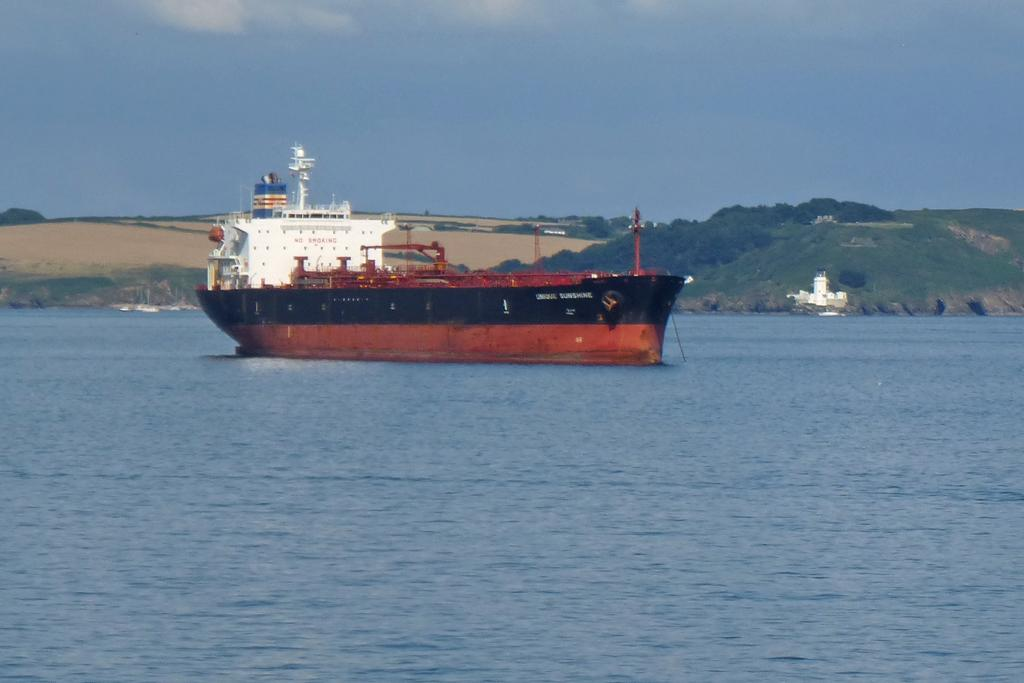What is the main subject of the image? There is a ship in the image. Where is the ship located? The ship is on the water. What can be seen in the background of the image? There are hills, buildings, and the sky visible in the background of the image. What is the condition of the sky in the image? Clouds are present in the sky. How many fingers can be seen holding the ship's wheel in the image? There are no fingers visible in the image, as it only shows the ship on the water with a background of hills, buildings, and a cloudy sky. 